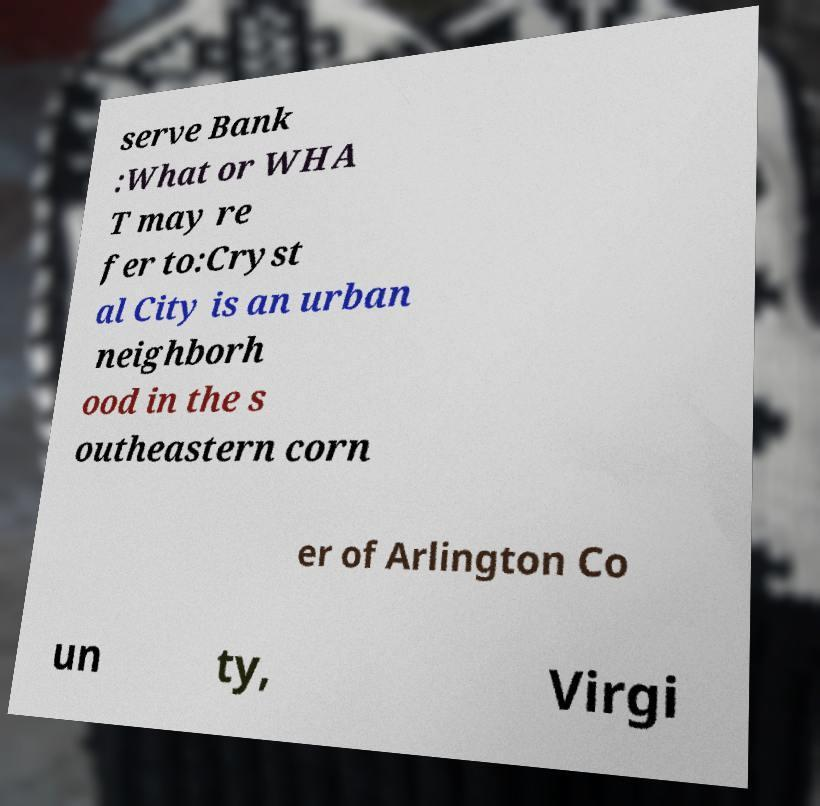Please identify and transcribe the text found in this image. serve Bank :What or WHA T may re fer to:Cryst al City is an urban neighborh ood in the s outheastern corn er of Arlington Co un ty, Virgi 